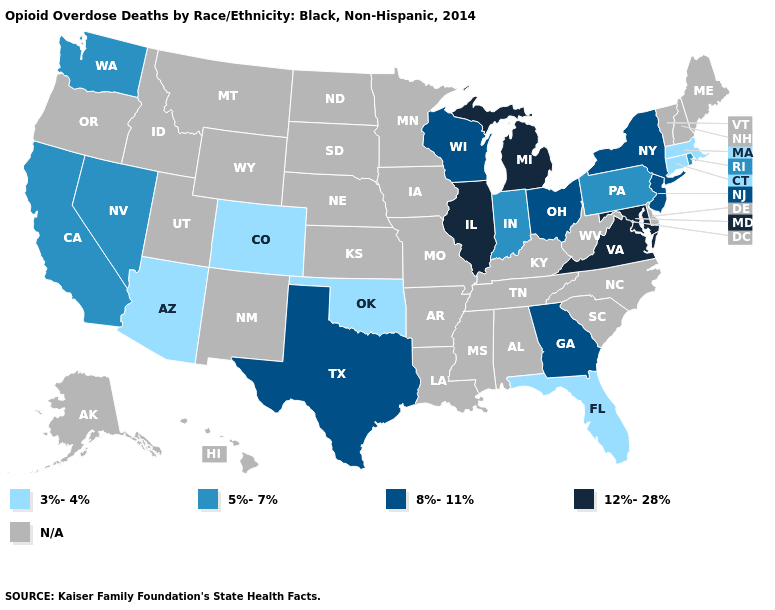Does Ohio have the highest value in the MidWest?
Write a very short answer. No. What is the highest value in the USA?
Be succinct. 12%-28%. What is the highest value in the MidWest ?
Be succinct. 12%-28%. What is the highest value in the USA?
Be succinct. 12%-28%. What is the value of Idaho?
Give a very brief answer. N/A. Among the states that border Oklahoma , which have the lowest value?
Keep it brief. Colorado. Name the states that have a value in the range 8%-11%?
Be succinct. Georgia, New Jersey, New York, Ohio, Texas, Wisconsin. What is the value of Arkansas?
Quick response, please. N/A. What is the value of Hawaii?
Short answer required. N/A. How many symbols are there in the legend?
Answer briefly. 5. Does the map have missing data?
Answer briefly. Yes. Does the first symbol in the legend represent the smallest category?
Concise answer only. Yes. Name the states that have a value in the range N/A?
Concise answer only. Alabama, Alaska, Arkansas, Delaware, Hawaii, Idaho, Iowa, Kansas, Kentucky, Louisiana, Maine, Minnesota, Mississippi, Missouri, Montana, Nebraska, New Hampshire, New Mexico, North Carolina, North Dakota, Oregon, South Carolina, South Dakota, Tennessee, Utah, Vermont, West Virginia, Wyoming. Does Massachusetts have the lowest value in the Northeast?
Keep it brief. Yes. Does California have the highest value in the West?
Concise answer only. Yes. 